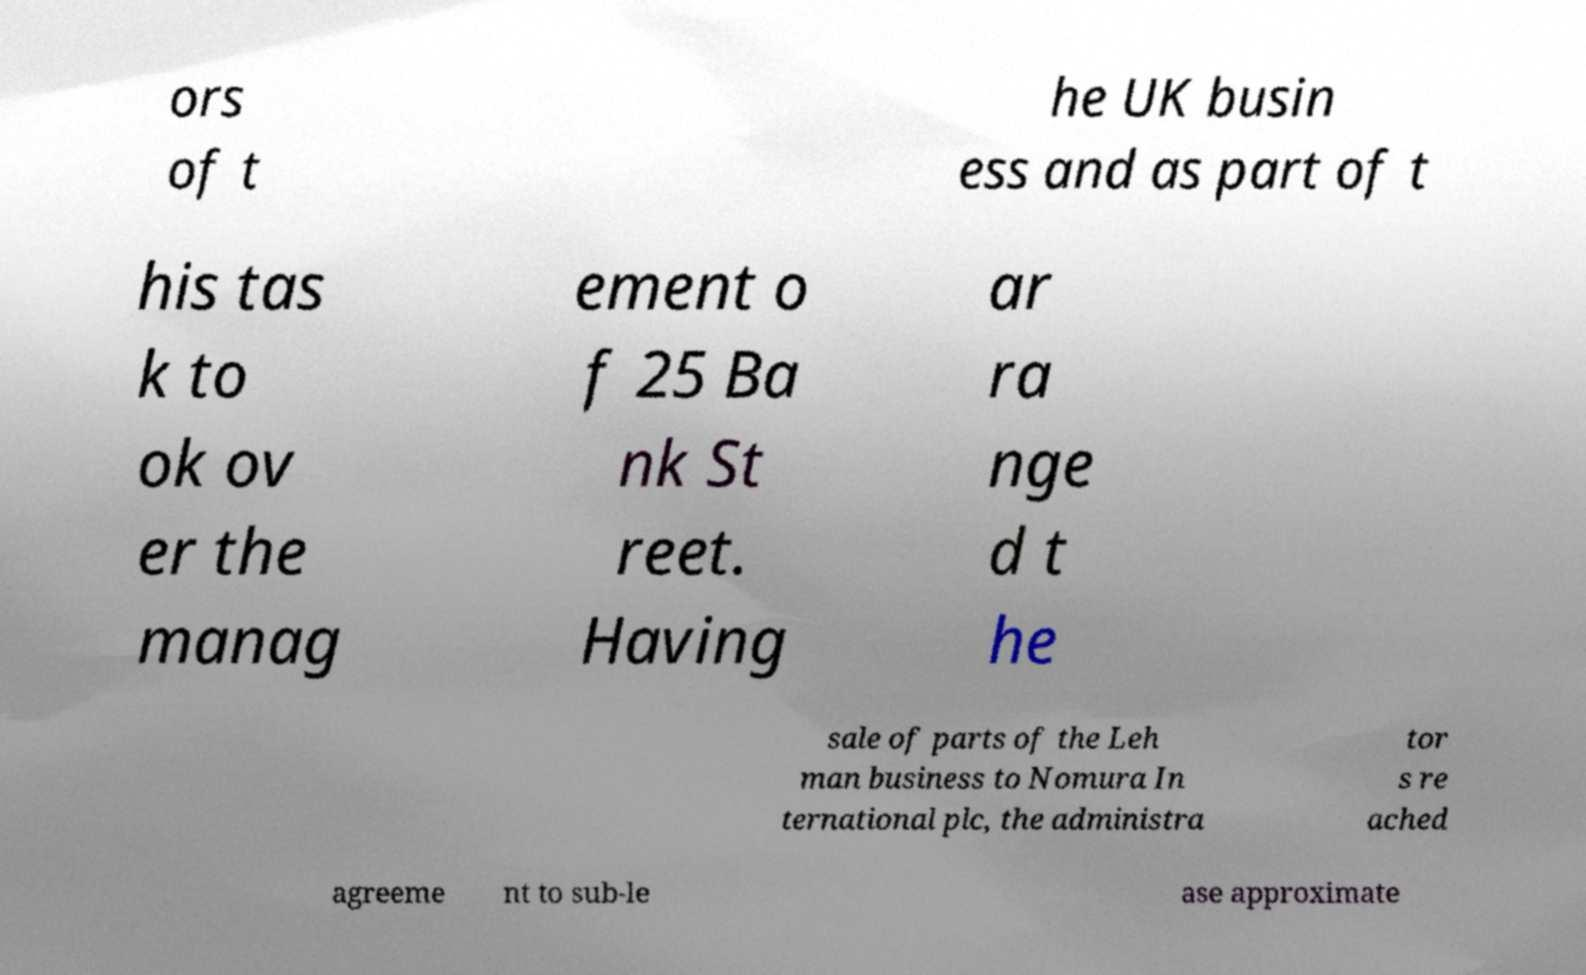Could you assist in decoding the text presented in this image and type it out clearly? ors of t he UK busin ess and as part of t his tas k to ok ov er the manag ement o f 25 Ba nk St reet. Having ar ra nge d t he sale of parts of the Leh man business to Nomura In ternational plc, the administra tor s re ached agreeme nt to sub-le ase approximate 